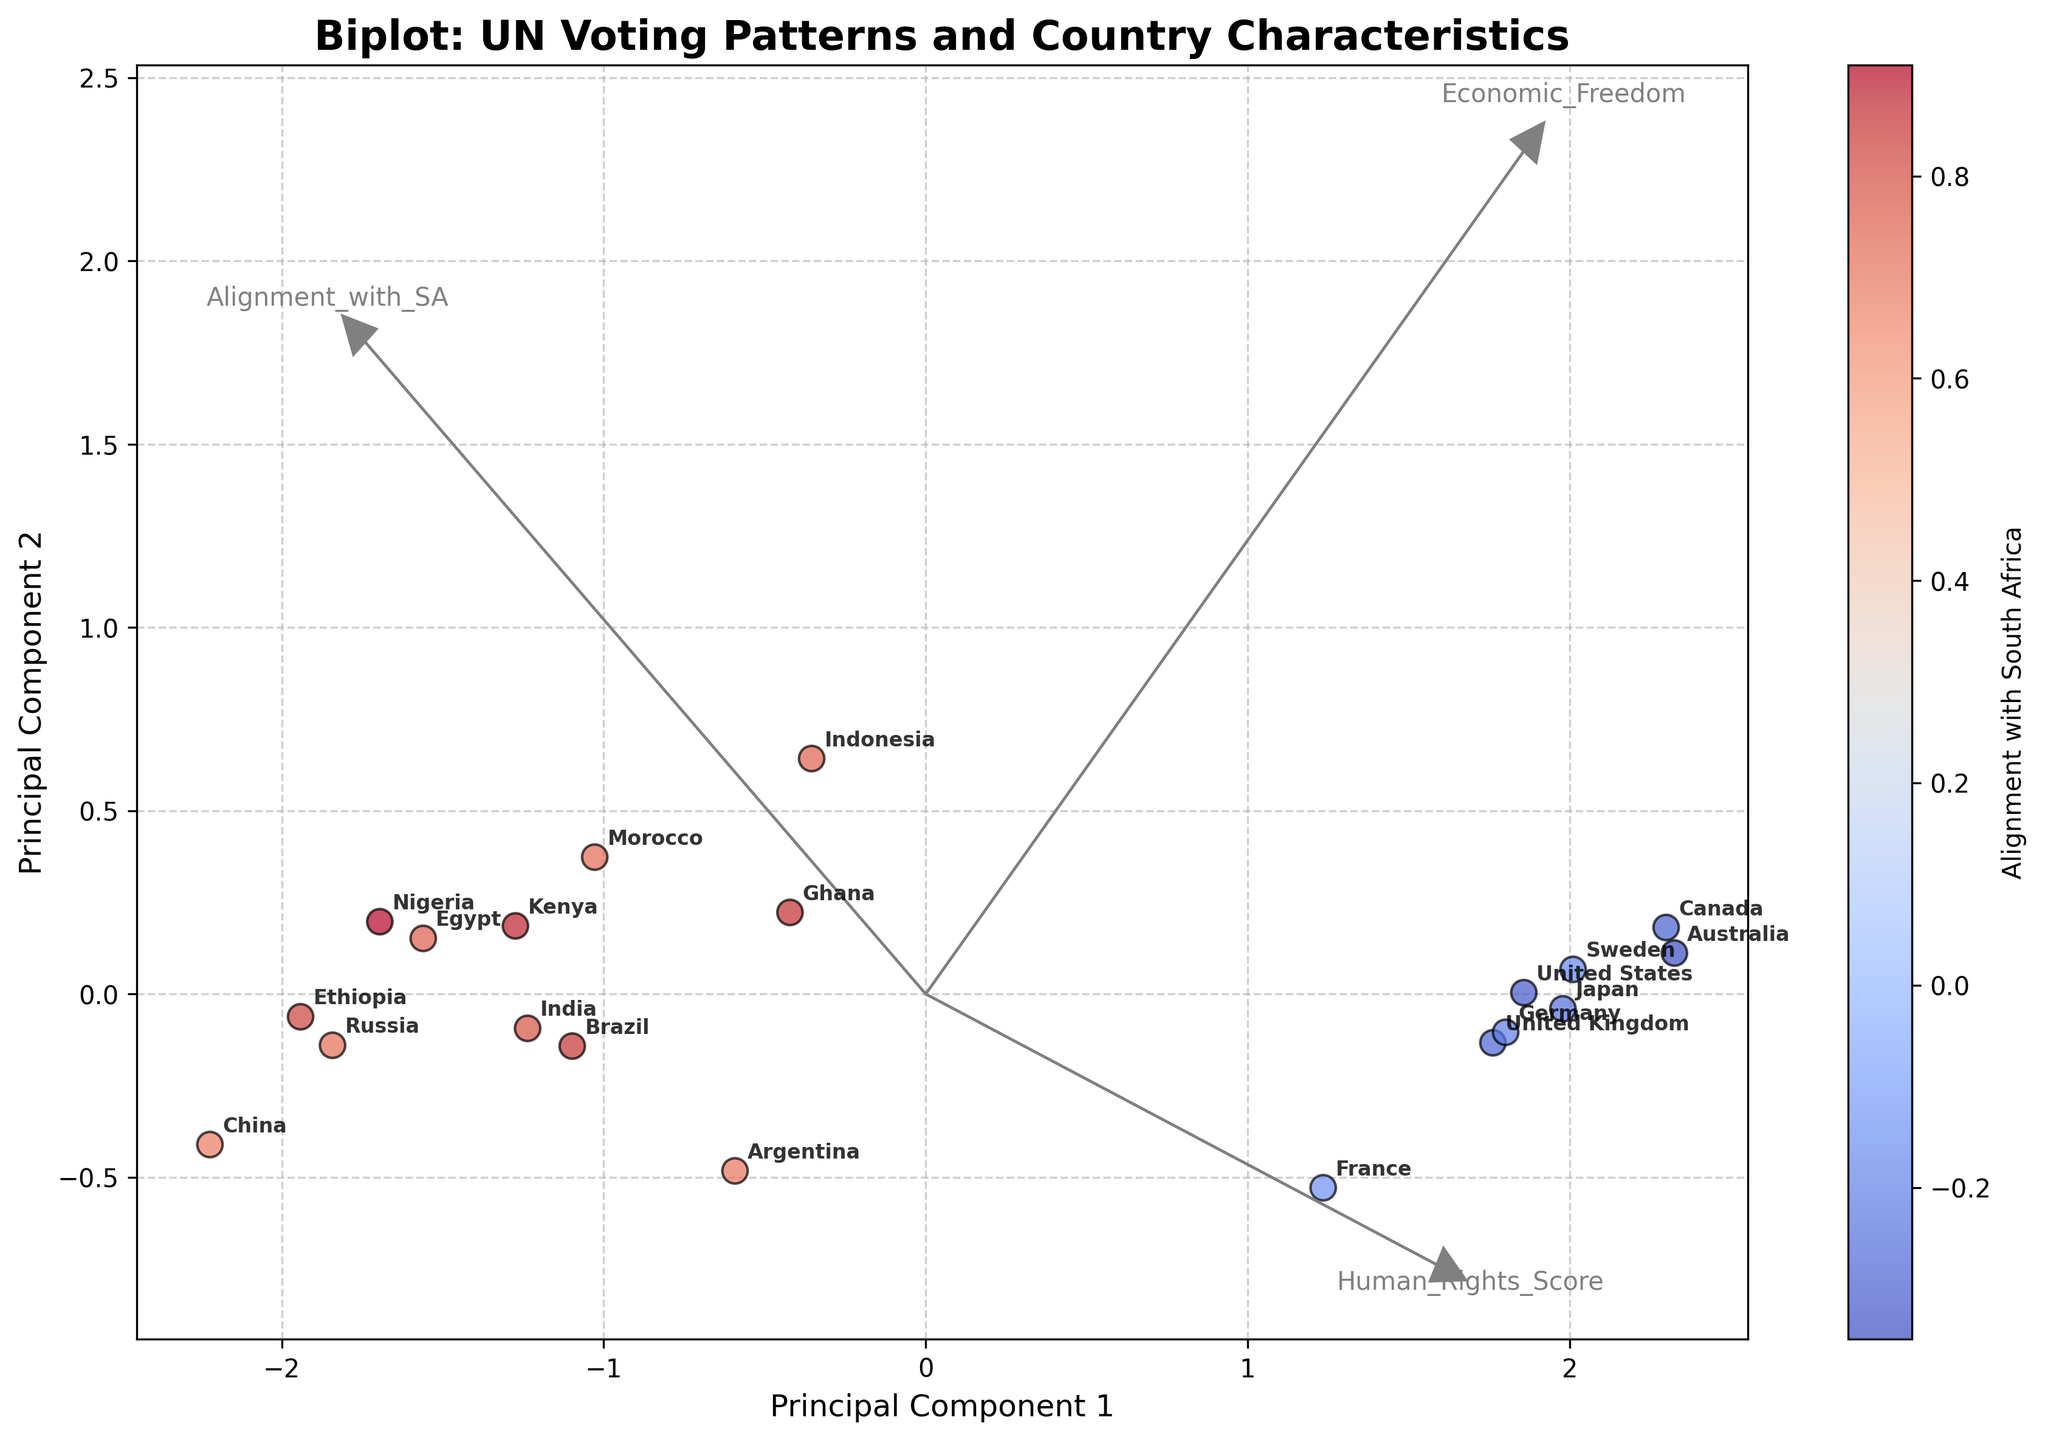How many arrows are used to plot the eigenvectors? The figure has eigenvectors plotted as arrows to demonstrate the direction of the principal components. We count the arrows in the plot.
Answer: 3 Which two countries show the highest alignment with South Africa? From the plot, countries are marked by their alignment values with South Africa. By observing the placement and intensity along the alignment color spectrum, we identify the two with the highest alignment.
Answer: Nigeria and Ghana Which country has the lowest alignment with South Africa? The plot’s color bar indicates the alignment with South Africa. We look for the country with the most negative alignment value.
Answer: Australia Based on the plot, does economic freedom or human rights have a stronger influence on the alignment with South Africa? By examining the directions and lengths of eigenvector arrows emanating from the origin, we determine which factor has a more substantial impact on alignment, indicated by how closely the arrows point in the direction of countries highly aligned with South Africa.
Answer: Human Rights Between the United States and China, which country has a greater economic freedom score? We compare the positions of the points representing the United States and China, observing their locations relative to the ‘Economic Freedom’ vector. The country whose data point is closer aligned with the direction of the economic freedom vector has the higher score.
Answer: United States If a country is aligned with South Africa, is it necessarily high in human rights? We infer this by observing the cluster of countries with high alignment with South Africa and noting their placement along the 'Human Rights Score' vector. This involves comparison and checking the trend across the plot.
Answer: No How many countries have a negative alignment with South Africa? We count the number of points colored with a negative value from the color bar, identifiable by the cooler (blue) colors.
Answer: 7 Is there any country that has both high human rights scores and high alignment with South Africa? We identify countries that have high alignment and are placed close to the 'Human Rights Score' vector. We then confirm if any country meets both criteria by cross-referencing both data points.
Answer: Ghana Which two countries are most similar in their positioning in the plot? We observe pairs of countries that lie closest to each other on the biplot in terms of their coordinates along the principal components to identify which pair is most similar.
Answer: Germany and United Kingdom Does the biplot show a clear distinction between countries with positive and negative alignment with South Africa? We analyze the spread and clustering of points divided by positive and negative alignment values, noting if there is a visible gap or overlap between the two groups.
Answer: Yes 